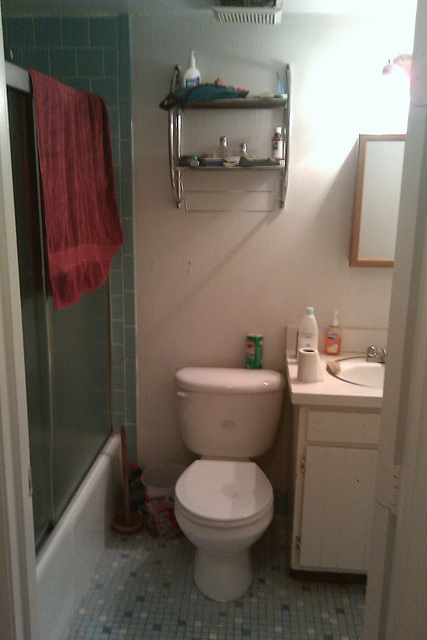<image>What on top of the glass shelf above the toilet? It is unknown what is on top of the glass shelf above the toilet. However, it could be lotions or bottles. What on top of the glass shelf above the toilet? I don't know what is on top of the glass shelf above the toilet. It can be lotions, toiletries, bottles, or something else. 